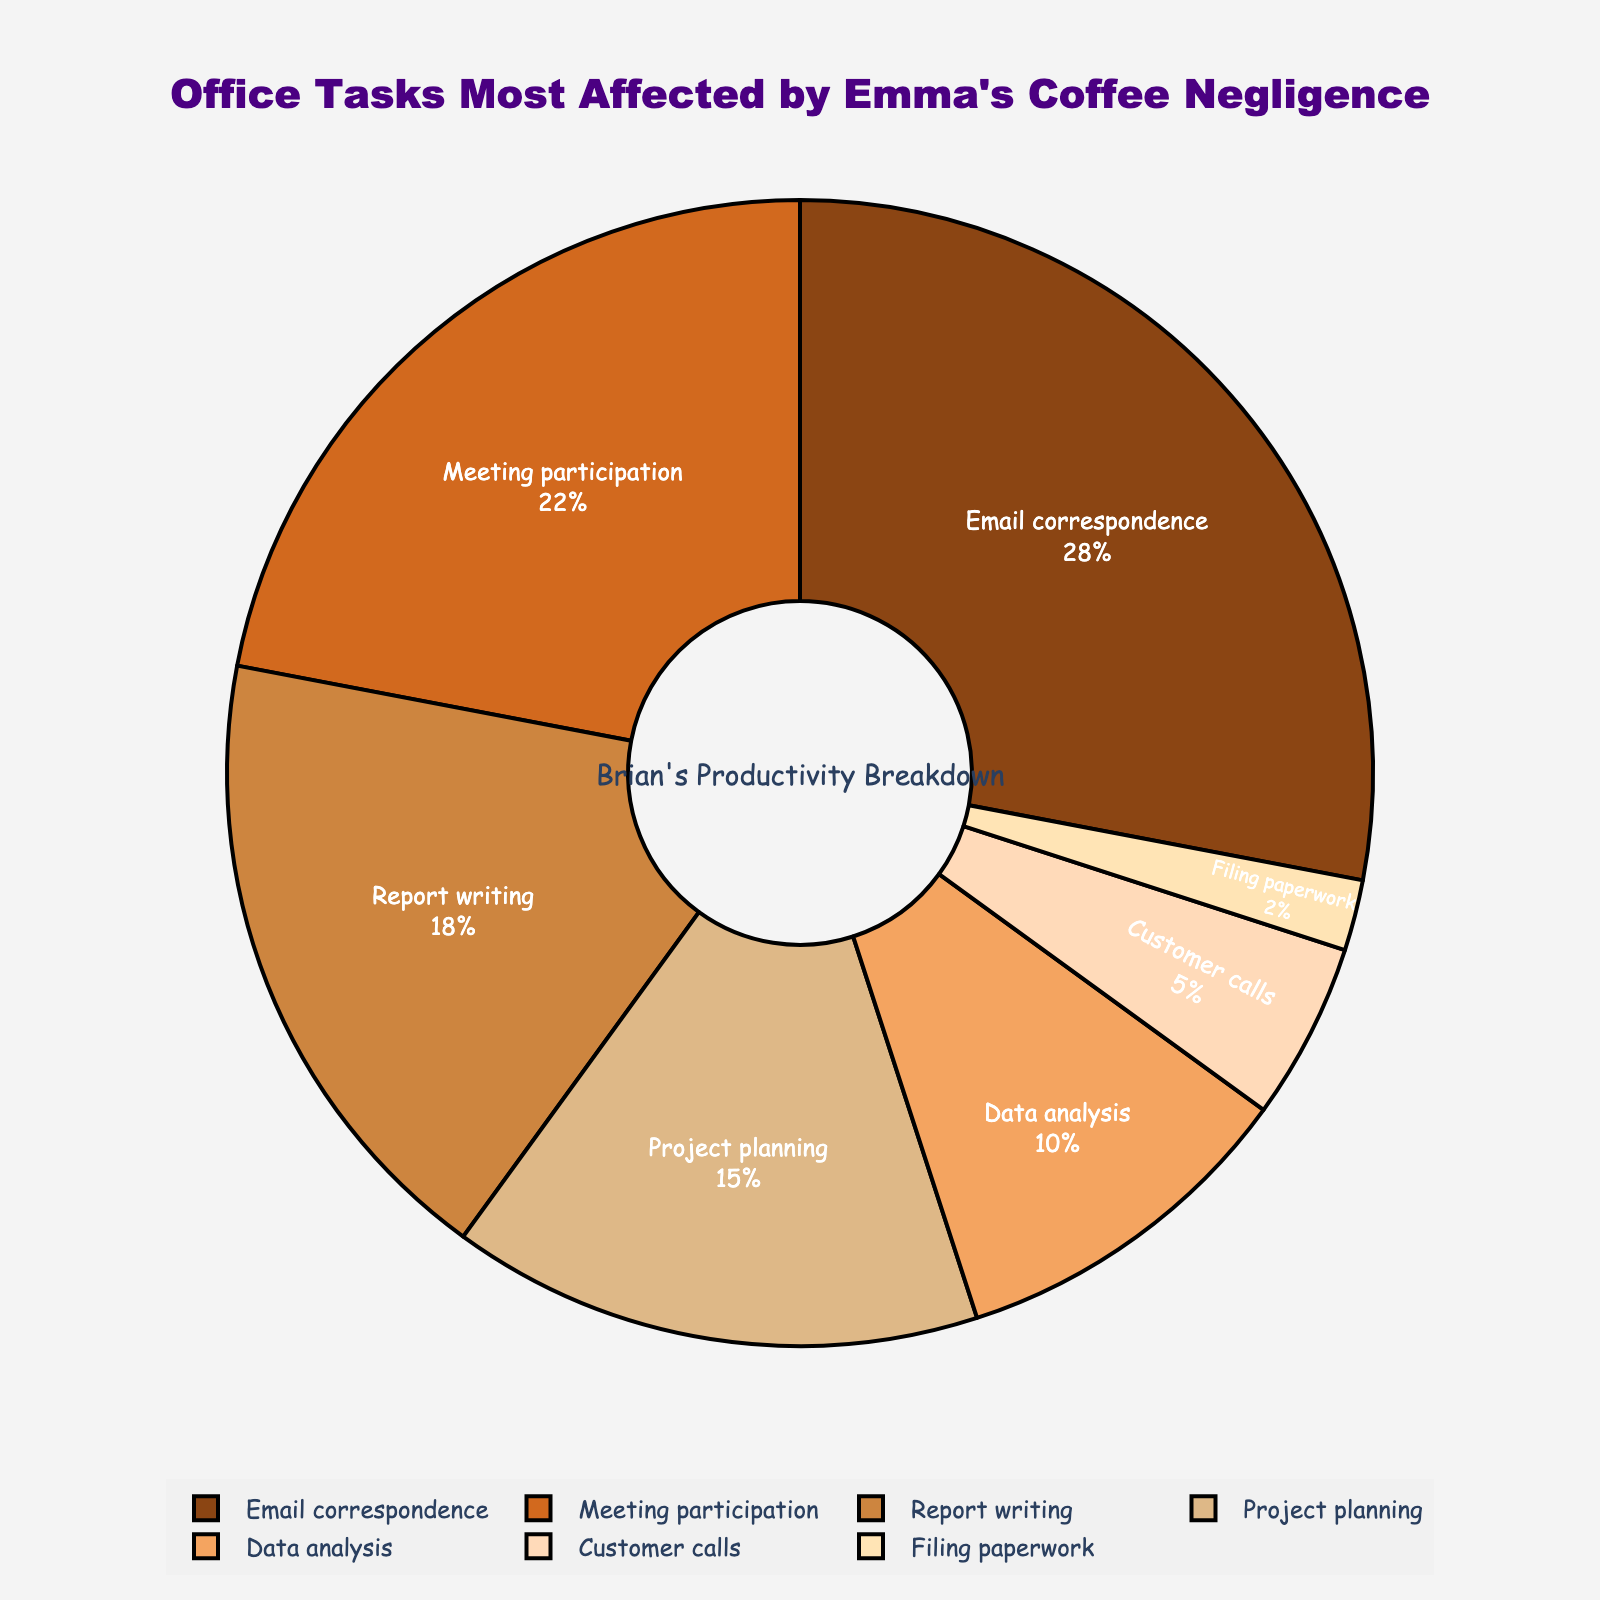What task stands out as the most affected by Emma's coffee negligence? Email correspondence has the largest percentage slice in the pie chart. This indicates it's the most affected task when Emma doesn't refill the coffee machine.
Answer: Email correspondence Which tasks combined are less affected than Email correspondence alone? Adding up the percentages for Data analysis, Customer calls, and Filing paperwork gives 10% + 5% + 2% = 17%, which is less than 28% for Email correspondence.
Answer: Data analysis, Customer calls, Filing paperwork In terms of percentage, how much more does lack of coffee affect Meeting participation compared to Filing paperwork? Meeting participation is 22% and Filing paperwork is 2%. The difference is 22% - 2% = 20%.
Answer: 20% What percentage do Project planning and Report writing together represent regarding the impact of lack of coffee? The sum of Project planning (15%) and Report writing (18%) is 15% + 18% = 33%.
Answer: 33% What task is least affected by Emma's coffee negligence according to the pie chart? Filing paperwork has the smallest percentage slice in the pie chart, indicating it is the least affected task.
Answer: Filing paperwork Which color represents Report writing? Report writing is represented by a color in the range of brown and its shades. Visually inspecting the pie chart, it seems to correlate with a lighter brown slice.
Answer: Light brown What is the ratio of the impact of lack of coffee on Email correspondence to Customer calls? Email correspondence is 28% and Customer calls are 5%. The ratio is 28:5.
Answer: 28:5 How does the impact on Project planning compare to that on Filing paperwork in terms of visual proportion? Project planning occupies a significantly larger portion of the pie chart compared to Filing paperwork, showing it is more affected visually.
Answer: Larger If you combine the impacts of Data analysis and Customer calls, how does it compare to Meeting participation? Adding Data analysis (10%) and Customer calls (5%) gives 15%, which is less than Meeting participation (22%).
Answer: Less than Which task contributes more to the overall impact, Data analysis or Project planning? Project planning has a larger percentage (15%) compared to Data analysis (10%).
Answer: Project planning 